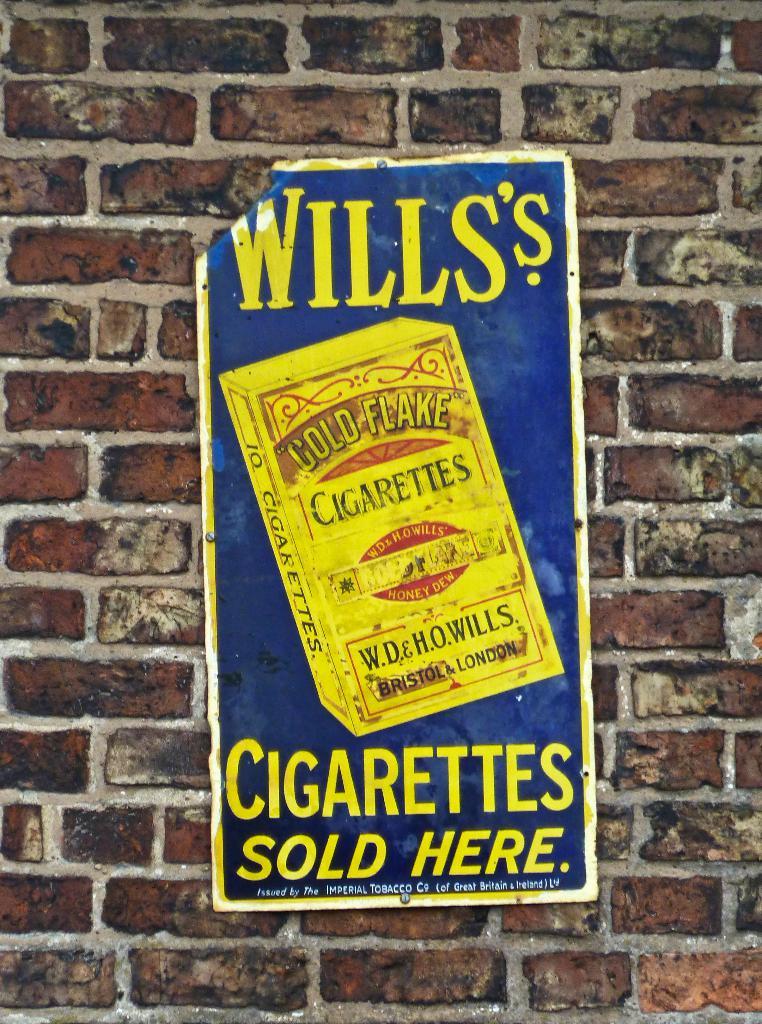What is sold here?
Keep it short and to the point. Cigarettes. What is the brand of the cigarettes?
Provide a short and direct response. Gold flake. 